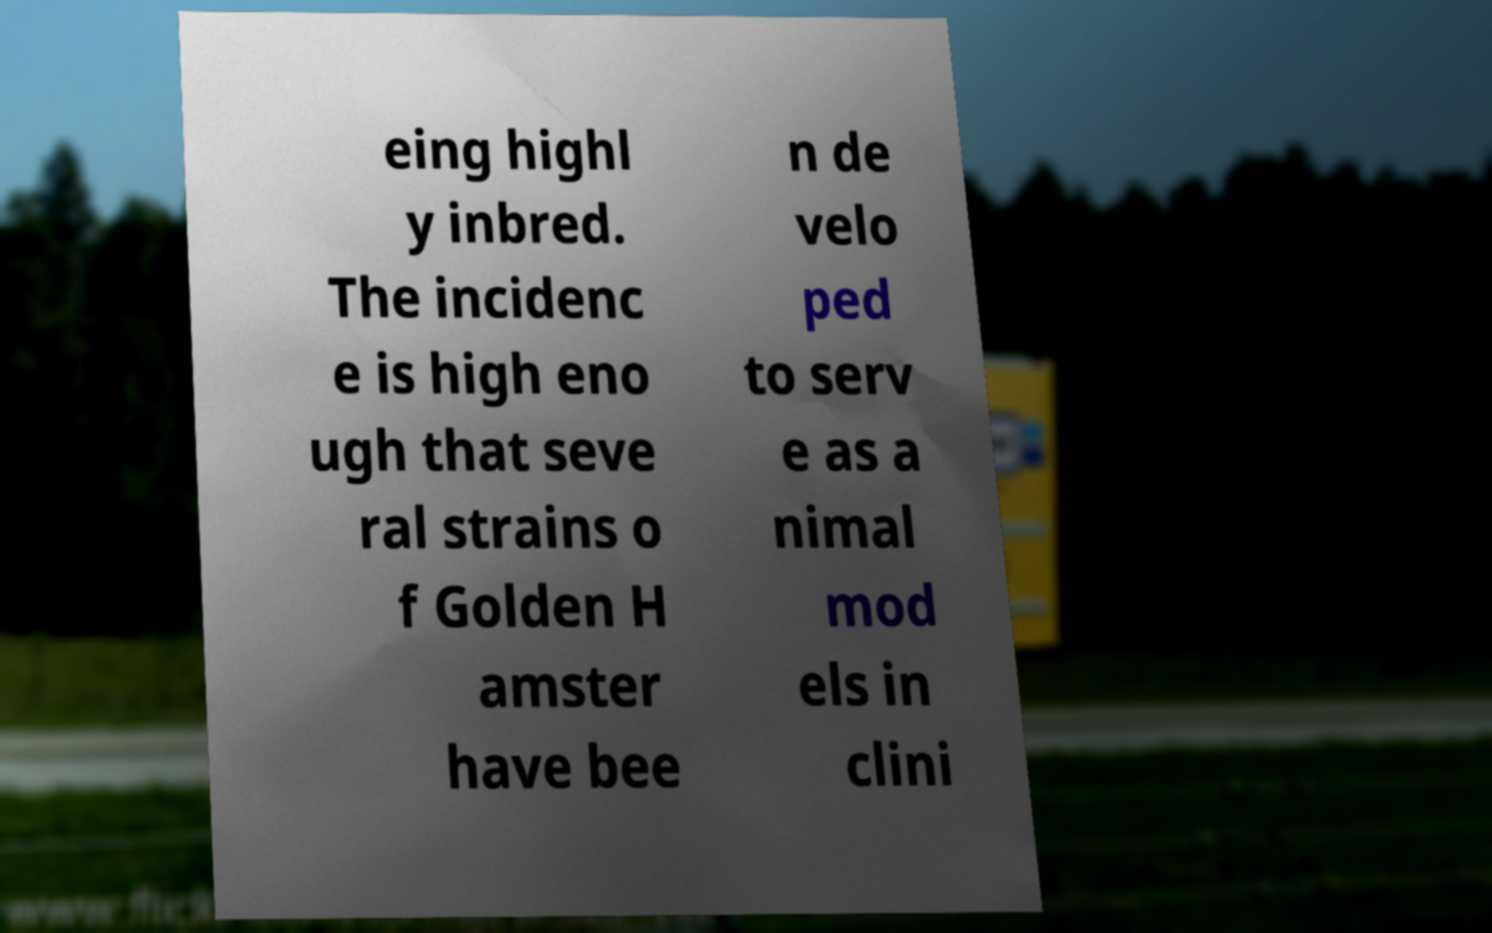For documentation purposes, I need the text within this image transcribed. Could you provide that? eing highl y inbred. The incidenc e is high eno ugh that seve ral strains o f Golden H amster have bee n de velo ped to serv e as a nimal mod els in clini 